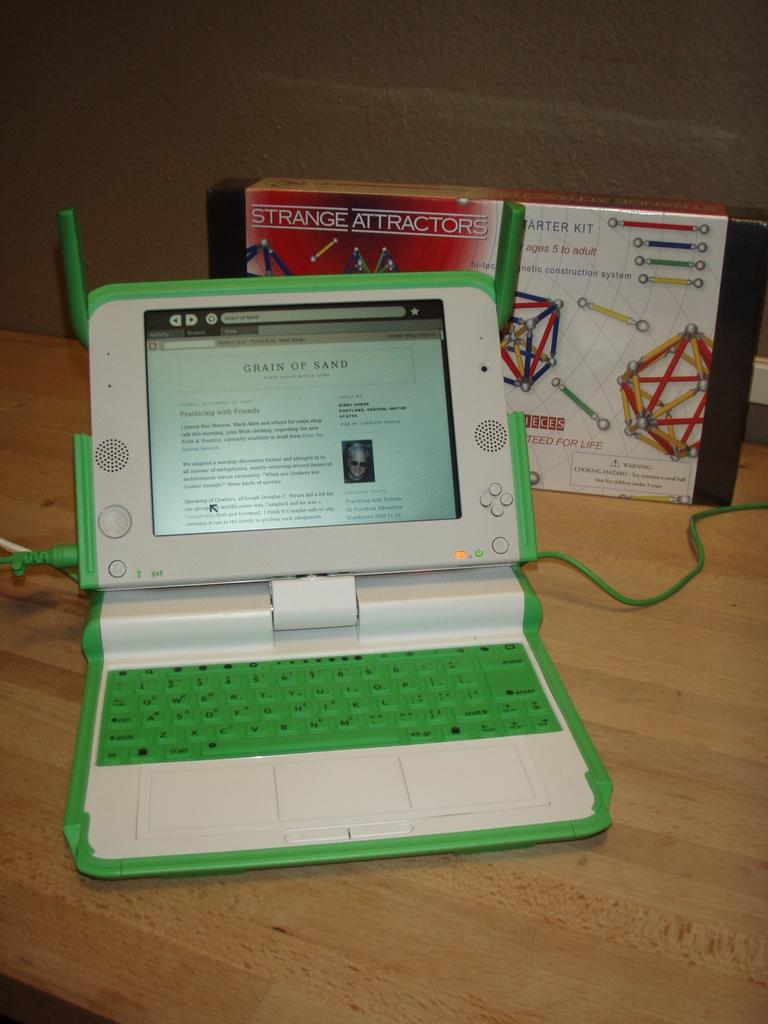What electronic device is visible in the image? There is a laptop in the image. What object is located behind the laptop? There is a box behind the laptop. What connects the laptop to another device or power source? A cable is present on the desk. Where are the laptop, box, and cable situated? They are all on a desk. What type of rock is being used as a doorstop in the image? There is no rock or doorstop present in the image. 